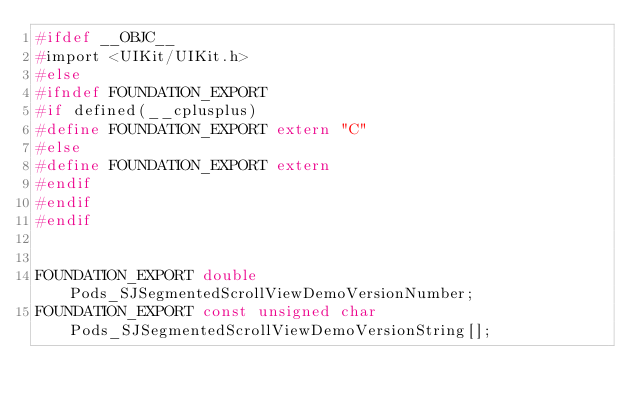Convert code to text. <code><loc_0><loc_0><loc_500><loc_500><_C_>#ifdef __OBJC__
#import <UIKit/UIKit.h>
#else
#ifndef FOUNDATION_EXPORT
#if defined(__cplusplus)
#define FOUNDATION_EXPORT extern "C"
#else
#define FOUNDATION_EXPORT extern
#endif
#endif
#endif


FOUNDATION_EXPORT double Pods_SJSegmentedScrollViewDemoVersionNumber;
FOUNDATION_EXPORT const unsigned char Pods_SJSegmentedScrollViewDemoVersionString[];

</code> 